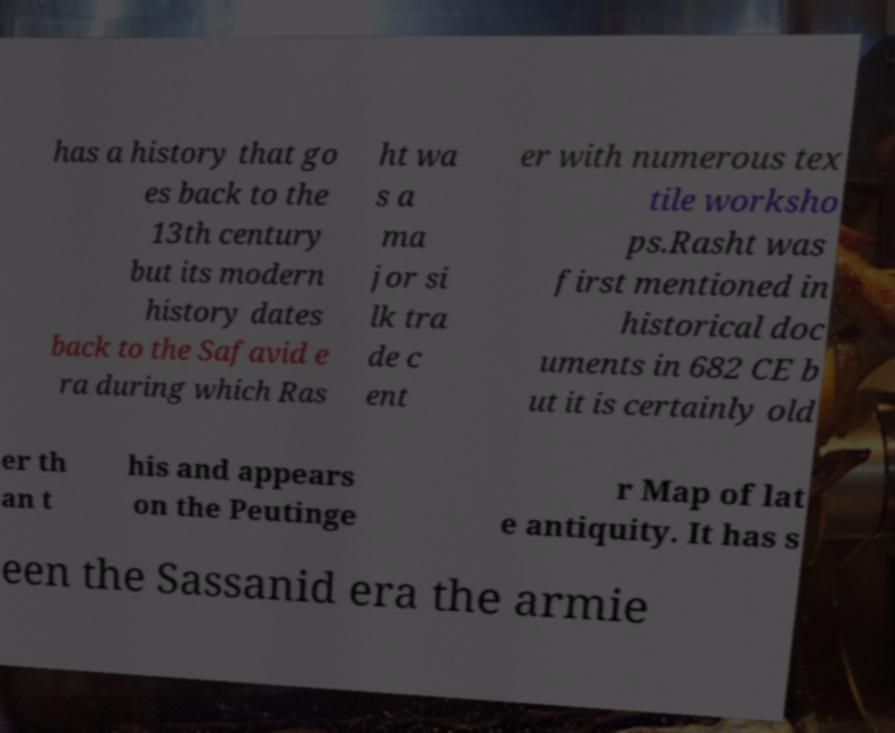Could you assist in decoding the text presented in this image and type it out clearly? has a history that go es back to the 13th century but its modern history dates back to the Safavid e ra during which Ras ht wa s a ma jor si lk tra de c ent er with numerous tex tile worksho ps.Rasht was first mentioned in historical doc uments in 682 CE b ut it is certainly old er th an t his and appears on the Peutinge r Map of lat e antiquity. It has s een the Sassanid era the armie 